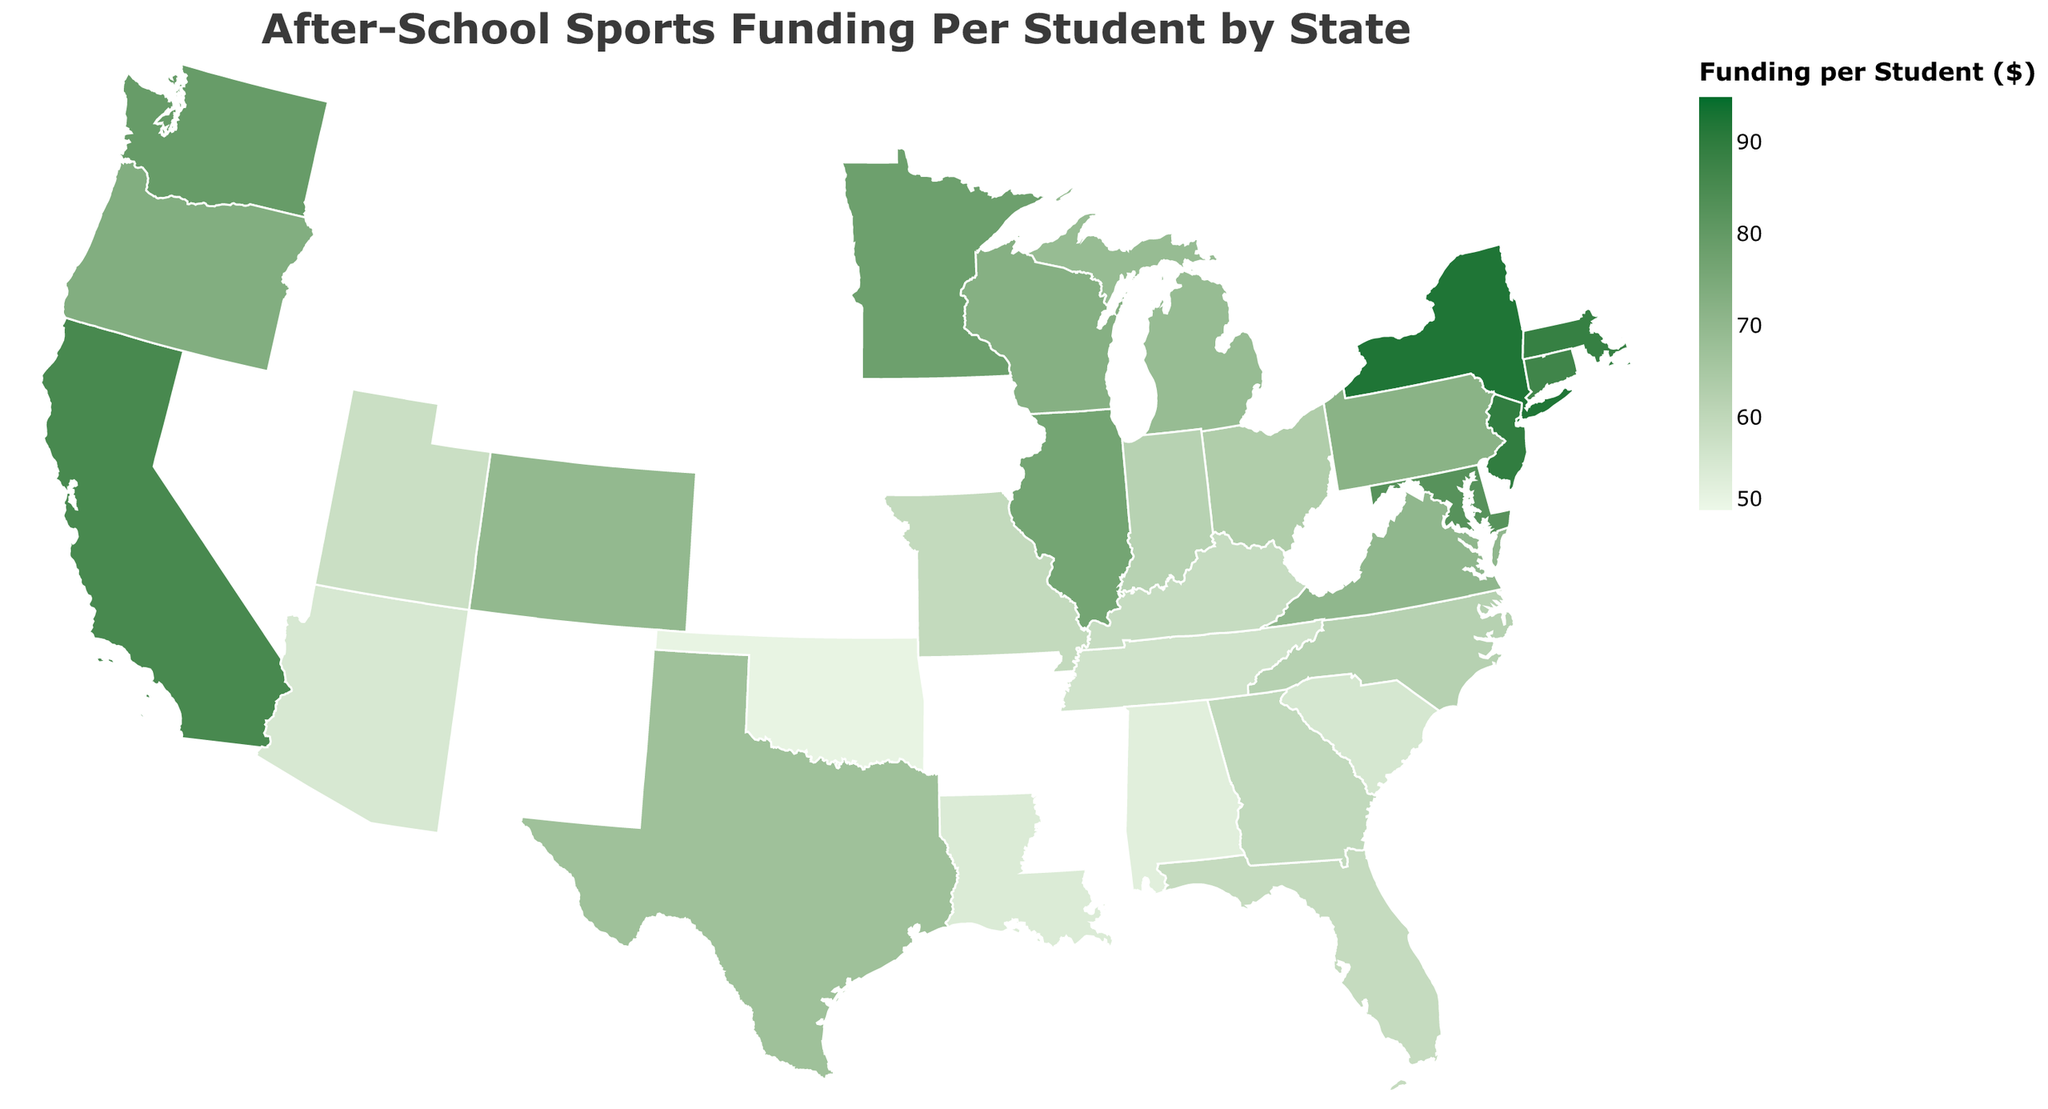Which state has the highest funding per student for after-school sports programs? Identify the state with the highest funding value by examining the color legend and tooltip information. New York has the highest funding per student at $92.30.
Answer: New York Which state has the lowest funding per student for after-school sports programs? Identify the state with the lowest funding value by examining the color legend and tooltip information. Oklahoma has the lowest funding per student at $51.20.
Answer: Oklahoma What is the funding per student in California compared to New York? Check the funding per student for both California and New York in the tooltip information. California has $85.50, and New York has $92.30; New York's funding is higher.
Answer: New York's funding is higher by $6.80 What is the average funding per student across all states? Sum all the funding values for each state and divide by the number of states. The sum is $2036.40 and there are 30 states. So, the average is $2036.40 / 30 ≈ $67.88.
Answer: $67.88 Which states have funding per student above $80? Identify states with a funding value above $80 by examining the color legend and tooltip information. States with funding per student above $80 are California, New York, New Jersey, Massachusetts, Maryland, and Connecticut.
Answer: California, New York, New Jersey, Massachusetts, Maryland, Connecticut How does Ohio's funding per student compare to the national average? Calculate the national average funding per student, then compare it to Ohio’s funding. The national average is $67.88, and Ohio has $63.50. Ohio’s funding is less than the national average by $4.38.
Answer: Ohio's funding is less by $4.38 Which region appears to have the most funding per student for after-school sports programs? Examine the colors for different regions and compare their funding per student. The Northeast region appears darker, indicating higher funding per student.
Answer: The Northeast What is the median funding per student across all states? List all states' funding values and find the middle value. The sorted funding values are: 51.20, 52.70, 53.90, 54.80, 55.20, 56.40, 57.80, 58.60, 58.90, 59.30, 59.70, 61.80, 62.10, 63.50, 67.20, 68.90, 69.80, 70.30, 71.80, 72.60, 73.40, 76.40, 77.90, 79.20, 82.50, 85.50, 86.90, 88.70, 89.60, 92.30. The middle value between 67.20 and 68.90 is the average of these two, which is (67.20 + 68.90) / 2 = 68.05.
Answer: $68.05 Which states have funding per student between $55 and $65? Identify the states with funding values between $55 and $65 by examining the tooltip information. The states are Florida, Georgia, North Carolina, Indiana, Missouri, South Carolina, Alabama, and Louisiana.
Answer: Florida, Georgia, North Carolina, Indiana, Missouri, South Carolina, Alabama, Louisiana What amount of funding is allocated per student in Wisconsin? Check the funding value for Wisconsin by examining the tooltip information. Wisconsin has funding per student at $72.60.
Answer: $72.60 